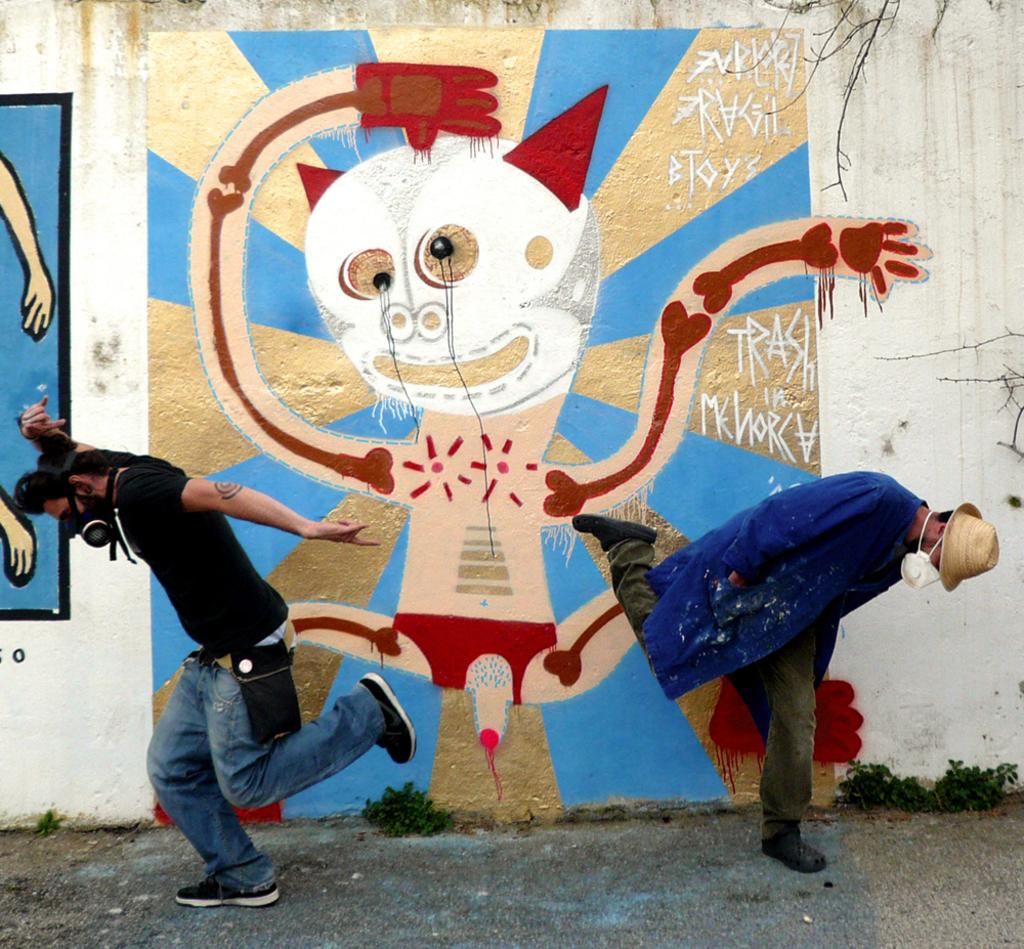How many people are visible in the image? There are two persons in the front of the image. What are the persons wearing on their faces? The persons are wearing masks. What can be seen in the background of the image? There is a wall in the background of the image. What is on the wall? There is graffiti on the wall. What type of vegetation is at the bottom of the image? There is a plant at the bottom of the image. What type of team is visible in the image? There is no team present in the image; it features two persons wearing masks. What color is the flesh of the persons in the image? There is no flesh visible in the image, as the persons are wearing masks that cover their faces. 